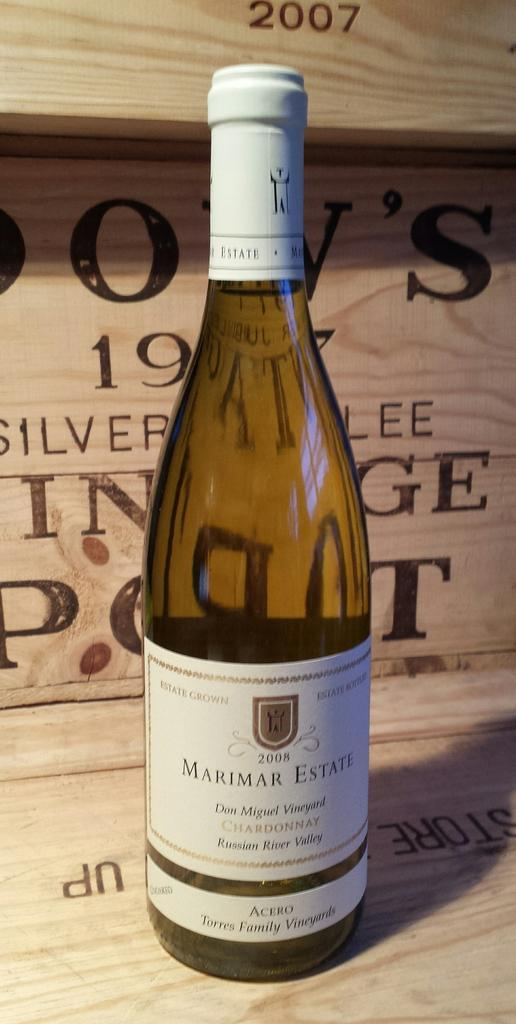<image>
Write a terse but informative summary of the picture. the word Marimar is on a beer bottle 